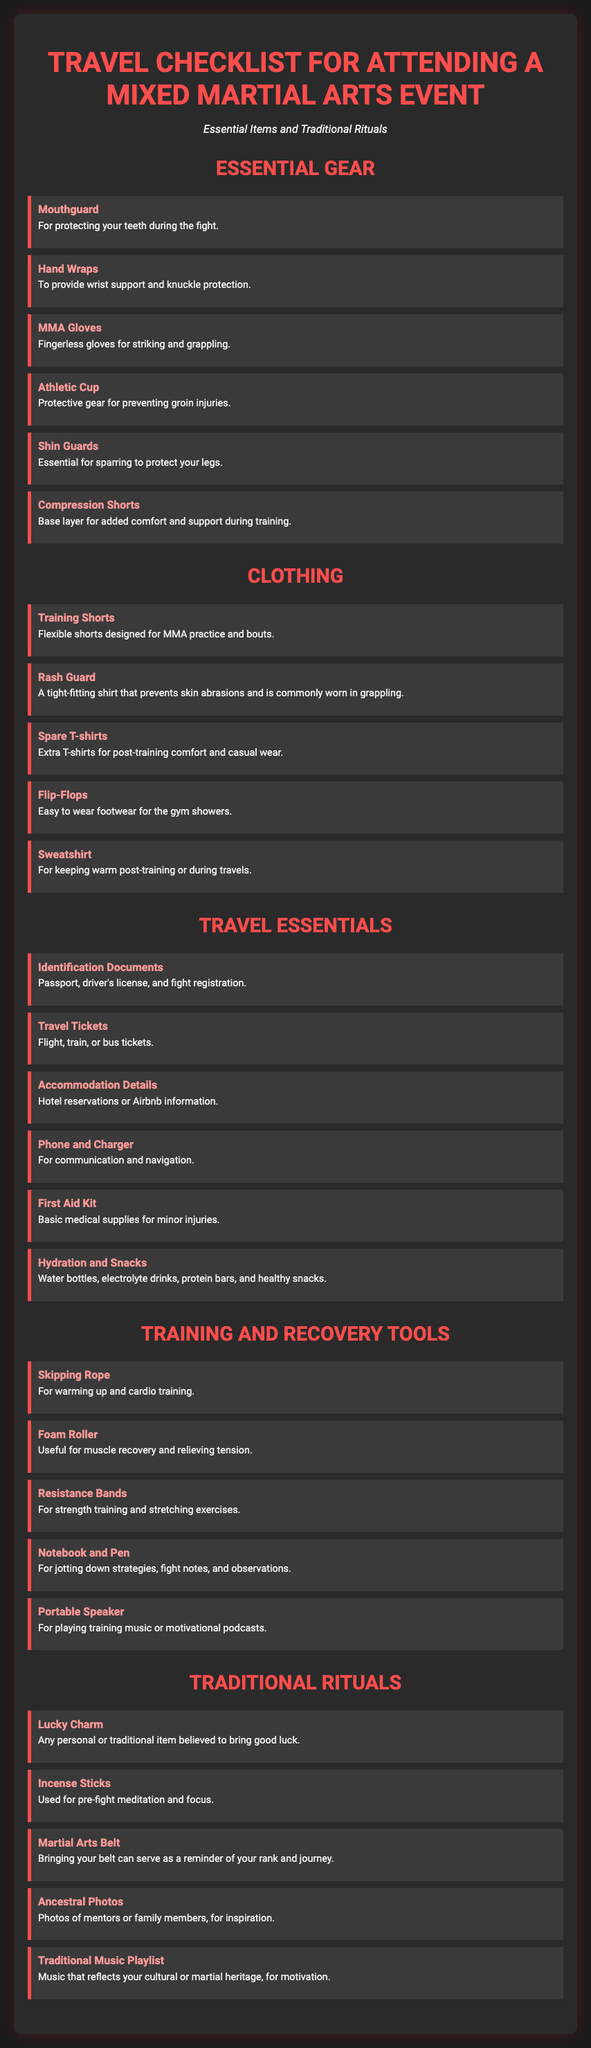What is the title of the document? The title is displayed prominently at the top of the document, indicating the focus on packing for an MMA event.
Answer: Travel Checklist for Attending a Mixed Martial Arts Event How many essential gear items are listed? The document provides a section that enumerates essential gear items critical for attendees.
Answer: 6 What item is used for pre-fight meditation? This item is included in the section discussing traditional rituals, specifically for focus during meditation.
Answer: Incense Sticks Which clothing item is designed for MMA practice? The document specifies a clothing category with an item specifically tailored for MMA sessions.
Answer: Training Shorts What should you bring to protect your teeth during a fight? The packing list mentions gear specifically related to dental protection.
Answer: Mouthguard What type of gloves are mentioned for striking? The item in the essential gear section explicitly states its purpose in the context of MMA.
Answer: MMA Gloves How many items are listed under Travel Essentials? A count of items can be derived from the clearly designated section of the document.
Answer: 6 